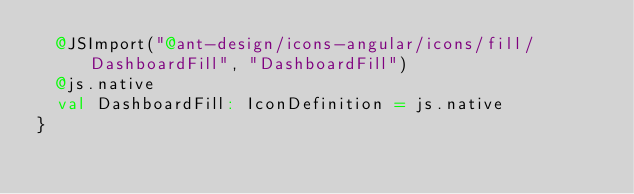Convert code to text. <code><loc_0><loc_0><loc_500><loc_500><_Scala_>  @JSImport("@ant-design/icons-angular/icons/fill/DashboardFill", "DashboardFill")
  @js.native
  val DashboardFill: IconDefinition = js.native
}
</code> 